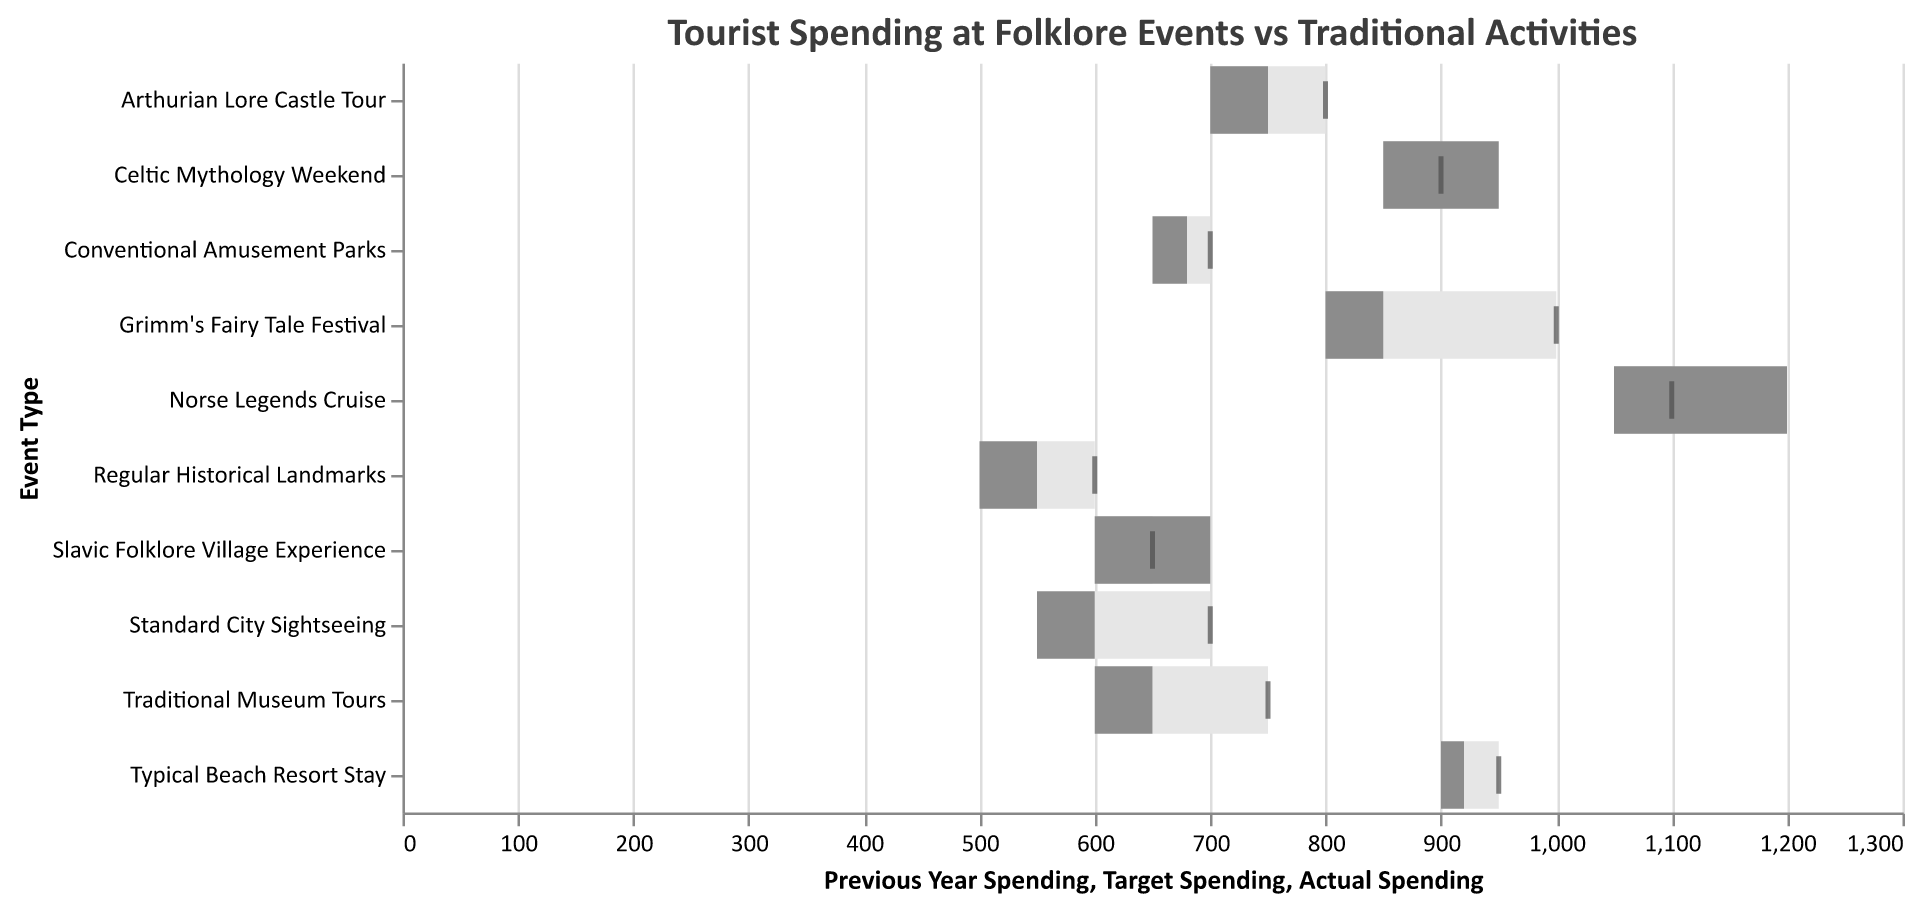What is the title of the figure? The title is typically displayed at the top of the figure and provides an overview of the visualized data. The title in this case is "Tourist Spending at Folklore Events vs Traditional Activities."
Answer: Tourist Spending at Folklore Events vs Traditional Activities Which event type had the highest actual spending? By looking at the length of the bars representing Actual Spending, we notice that the "Norse Legends Cruise" has the longest bar, indicating the highest spending.
Answer: Norse Legends Cruise What is the lowest actual spending event type? Comparing the length of the bars for all event types, the "Regular Historical Landmarks" has the shortest bar, showing the lowest actual spending.
Answer: Regular Historical Landmarks How does the actual spending on the "Grimm's Fairy Tale Festival" compare to its target spending? The light gray bar represents the actual spending and the dark gray bar extends to show the target spending. For "Grimm's Fairy Tale Festival," the actual spending bar is shorter than the target bar.
Answer: Less than the target What is the difference between actual spending and target spending for the "Typical Beach Resort Stay"? The light gray bar ends at 900 (actual) and the tick mark for the target is at 950. Subtracting gives us 950 - 900 = 50.
Answer: 50 Which folklore-based event exceeded its target spending? Look at the bars against the tick marks for target spending. The only folklore-based event where the actual spending bar surpasses the target tick mark is "Celtic Mythology Weekend."
Answer: Celtic Mythology Weekend Compare the actual spending for "Arthurian Lore Castle Tour" with "Standard City Sightseeing." The bar for "Arthurian Lore Castle Tour" ends at 750 while the bar for "Standard City Sightseeing" ends at 550. The actual spending for "Arthurian Lore Castle Tour" is higher.
Answer: Arthurian Lore Castle Tour is higher How does previous year spending of "Slavic Folklore Village Experience" differ from its current actual spending? The light gray bar shows previous year spending at 600 and the actual spending bar at 700, giving us a difference of 700 - 600 = 100.
Answer: 100 What is the total target spending for all traditional activities combined? Sum up the target spending of traditional activities only: "Traditional Museum Tours" (750), "Standard City Sightseeing" (700), "Regular Historical Landmarks" (600), and "Conventional Amusement Parks" (700). Total = 750 + 700 + 600 + 700 = 2750.
Answer: 2750 Among the events, which one shows the highest increase in actual spending compared to the previous year? Compare the increments (actual - previous year) for each event. "Norse Legends Cruise" shows the highest increase: 1200 (actual) - 1050 (previous year) = 150.
Answer: Norse Legends Cruise 